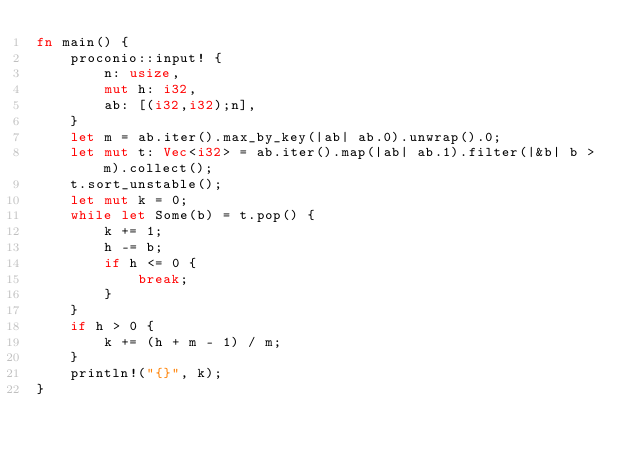<code> <loc_0><loc_0><loc_500><loc_500><_Rust_>fn main() {
    proconio::input! {
        n: usize,
        mut h: i32,
        ab: [(i32,i32);n],
    }
    let m = ab.iter().max_by_key(|ab| ab.0).unwrap().0;
    let mut t: Vec<i32> = ab.iter().map(|ab| ab.1).filter(|&b| b > m).collect();
    t.sort_unstable();
    let mut k = 0;
    while let Some(b) = t.pop() {
        k += 1;
        h -= b;
        if h <= 0 {
            break;
        }
    }
    if h > 0 {
        k += (h + m - 1) / m;
    }
    println!("{}", k);
}
</code> 